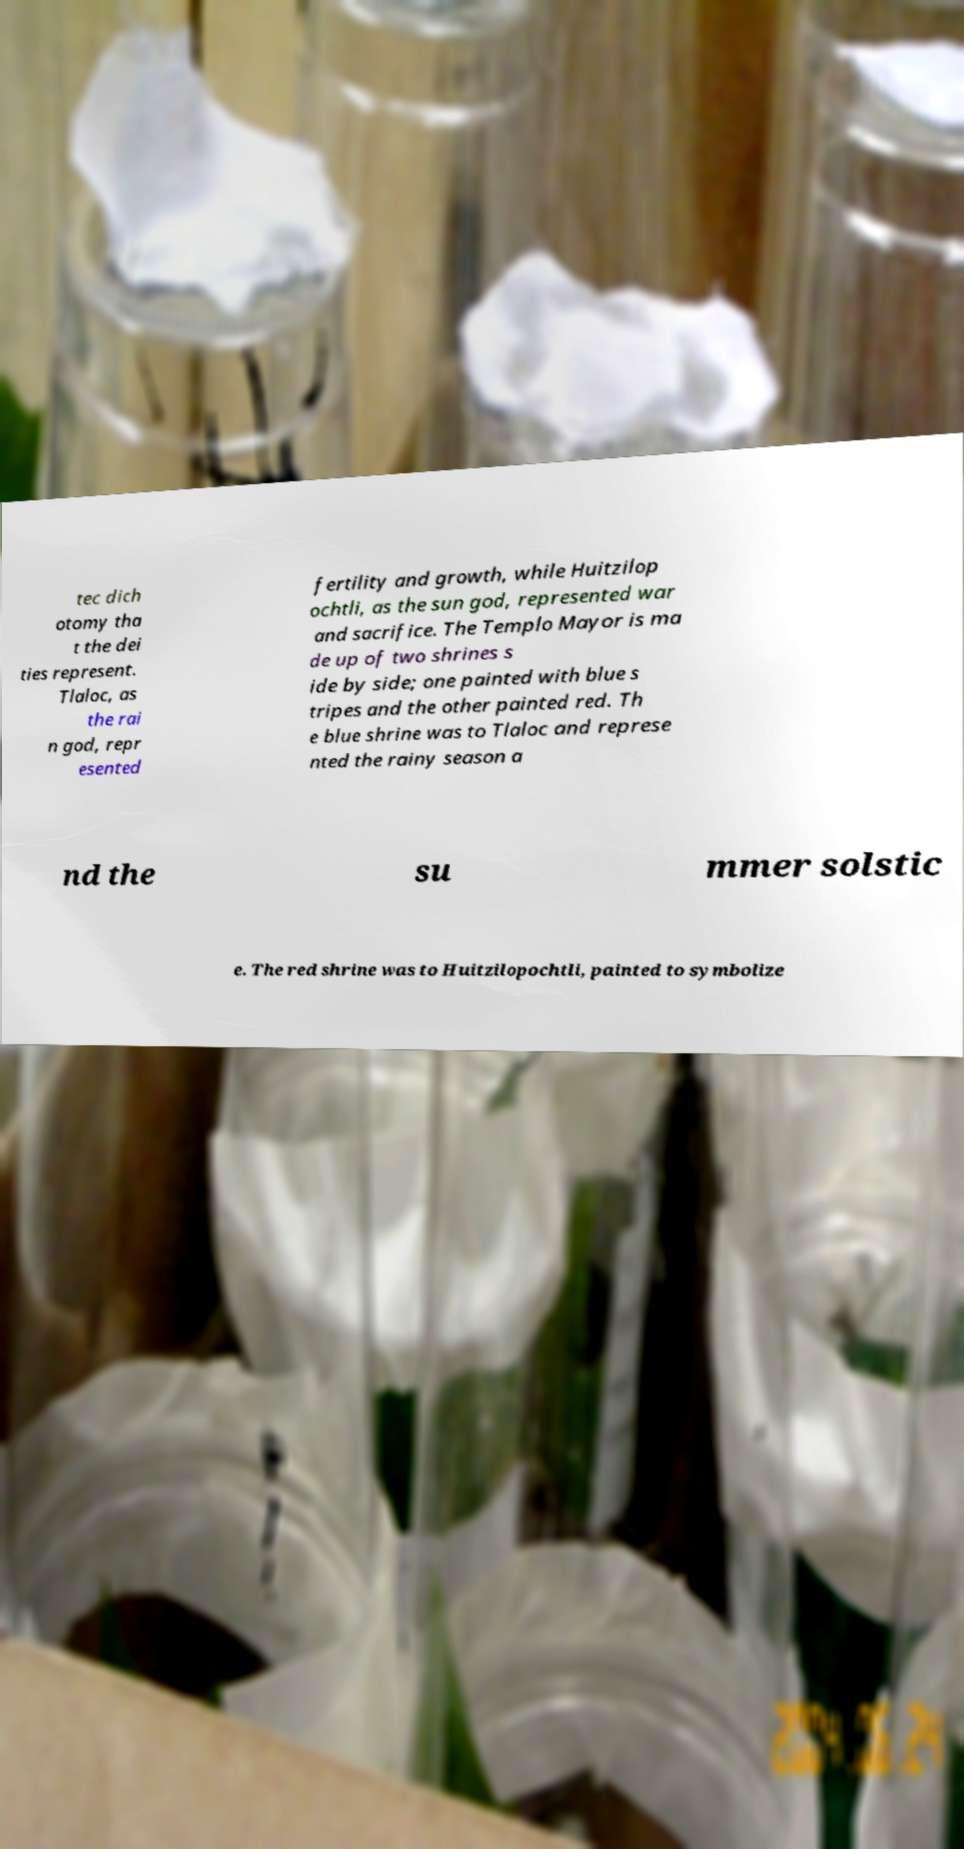There's text embedded in this image that I need extracted. Can you transcribe it verbatim? tec dich otomy tha t the dei ties represent. Tlaloc, as the rai n god, repr esented fertility and growth, while Huitzilop ochtli, as the sun god, represented war and sacrifice. The Templo Mayor is ma de up of two shrines s ide by side; one painted with blue s tripes and the other painted red. Th e blue shrine was to Tlaloc and represe nted the rainy season a nd the su mmer solstic e. The red shrine was to Huitzilopochtli, painted to symbolize 